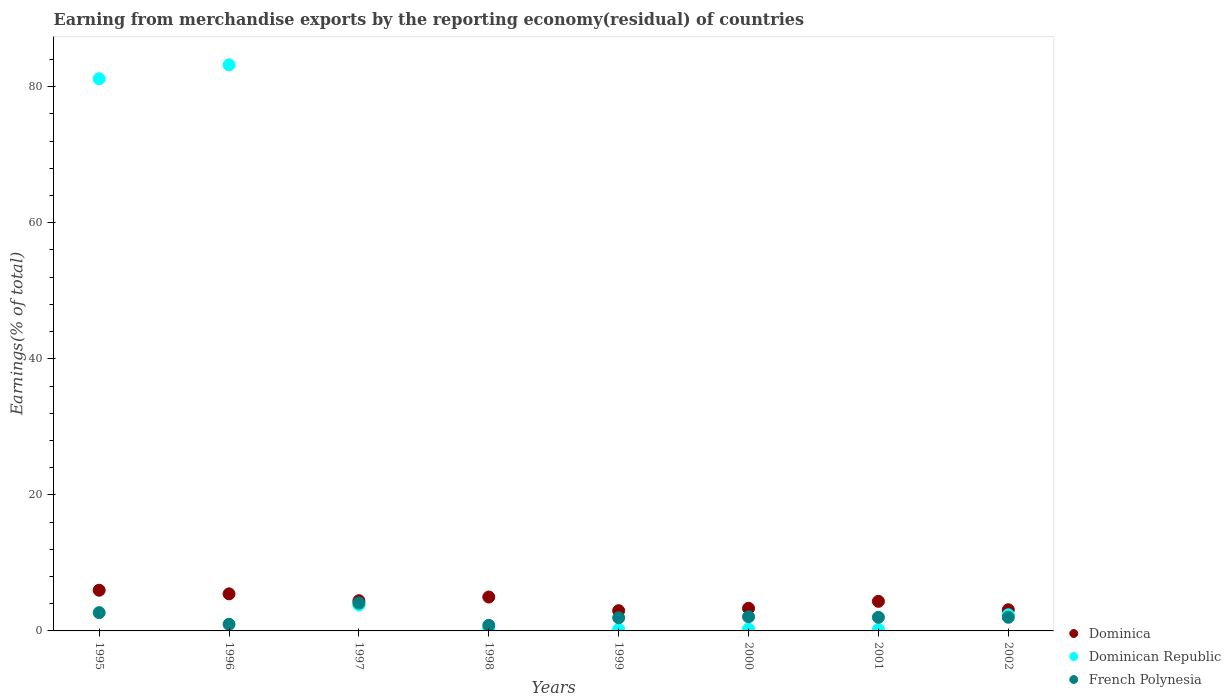How many different coloured dotlines are there?
Offer a terse response. 3. Is the number of dotlines equal to the number of legend labels?
Make the answer very short. Yes. What is the percentage of amount earned from merchandise exports in Dominica in 2001?
Offer a very short reply. 4.35. Across all years, what is the maximum percentage of amount earned from merchandise exports in French Polynesia?
Your answer should be very brief. 4.1. Across all years, what is the minimum percentage of amount earned from merchandise exports in Dominican Republic?
Keep it short and to the point. 0.22. In which year was the percentage of amount earned from merchandise exports in French Polynesia minimum?
Provide a succinct answer. 1998. What is the total percentage of amount earned from merchandise exports in Dominica in the graph?
Offer a terse response. 34.62. What is the difference between the percentage of amount earned from merchandise exports in French Polynesia in 1998 and that in 2001?
Ensure brevity in your answer.  -1.18. What is the difference between the percentage of amount earned from merchandise exports in Dominica in 1999 and the percentage of amount earned from merchandise exports in French Polynesia in 2000?
Offer a very short reply. 0.9. What is the average percentage of amount earned from merchandise exports in Dominican Republic per year?
Give a very brief answer. 21.45. In the year 2000, what is the difference between the percentage of amount earned from merchandise exports in Dominican Republic and percentage of amount earned from merchandise exports in French Polynesia?
Provide a succinct answer. -1.81. What is the ratio of the percentage of amount earned from merchandise exports in Dominican Republic in 1997 to that in 1998?
Provide a succinct answer. 11.71. Is the percentage of amount earned from merchandise exports in Dominica in 1996 less than that in 2001?
Your answer should be compact. No. Is the difference between the percentage of amount earned from merchandise exports in Dominican Republic in 1996 and 1999 greater than the difference between the percentage of amount earned from merchandise exports in French Polynesia in 1996 and 1999?
Offer a terse response. Yes. What is the difference between the highest and the second highest percentage of amount earned from merchandise exports in French Polynesia?
Your answer should be compact. 1.42. What is the difference between the highest and the lowest percentage of amount earned from merchandise exports in Dominican Republic?
Make the answer very short. 83. Does the percentage of amount earned from merchandise exports in Dominica monotonically increase over the years?
Ensure brevity in your answer.  No. Is the percentage of amount earned from merchandise exports in Dominican Republic strictly greater than the percentage of amount earned from merchandise exports in French Polynesia over the years?
Provide a succinct answer. No. Is the percentage of amount earned from merchandise exports in Dominican Republic strictly less than the percentage of amount earned from merchandise exports in French Polynesia over the years?
Keep it short and to the point. No. Does the graph contain any zero values?
Offer a terse response. No. How many legend labels are there?
Provide a short and direct response. 3. What is the title of the graph?
Your answer should be very brief. Earning from merchandise exports by the reporting economy(residual) of countries. Does "Romania" appear as one of the legend labels in the graph?
Provide a succinct answer. No. What is the label or title of the Y-axis?
Make the answer very short. Earnings(% of total). What is the Earnings(% of total) of Dominica in 1995?
Your answer should be compact. 5.98. What is the Earnings(% of total) of Dominican Republic in 1995?
Provide a succinct answer. 81.17. What is the Earnings(% of total) of French Polynesia in 1995?
Keep it short and to the point. 2.69. What is the Earnings(% of total) in Dominica in 1996?
Keep it short and to the point. 5.45. What is the Earnings(% of total) in Dominican Republic in 1996?
Your response must be concise. 83.22. What is the Earnings(% of total) of French Polynesia in 1996?
Offer a terse response. 0.98. What is the Earnings(% of total) in Dominica in 1997?
Your answer should be compact. 4.44. What is the Earnings(% of total) in Dominican Republic in 1997?
Provide a succinct answer. 3.8. What is the Earnings(% of total) of French Polynesia in 1997?
Keep it short and to the point. 4.1. What is the Earnings(% of total) in Dominica in 1998?
Provide a short and direct response. 4.98. What is the Earnings(% of total) of Dominican Republic in 1998?
Offer a very short reply. 0.32. What is the Earnings(% of total) in French Polynesia in 1998?
Your answer should be very brief. 0.82. What is the Earnings(% of total) in Dominica in 1999?
Provide a succinct answer. 2.97. What is the Earnings(% of total) of Dominican Republic in 1999?
Keep it short and to the point. 0.23. What is the Earnings(% of total) in French Polynesia in 1999?
Your answer should be very brief. 1.93. What is the Earnings(% of total) of Dominica in 2000?
Make the answer very short. 3.32. What is the Earnings(% of total) in Dominican Republic in 2000?
Make the answer very short. 0.27. What is the Earnings(% of total) in French Polynesia in 2000?
Provide a short and direct response. 2.08. What is the Earnings(% of total) of Dominica in 2001?
Give a very brief answer. 4.35. What is the Earnings(% of total) of Dominican Republic in 2001?
Provide a succinct answer. 0.22. What is the Earnings(% of total) of French Polynesia in 2001?
Offer a terse response. 2. What is the Earnings(% of total) in Dominica in 2002?
Provide a short and direct response. 3.11. What is the Earnings(% of total) in Dominican Republic in 2002?
Make the answer very short. 2.38. What is the Earnings(% of total) in French Polynesia in 2002?
Give a very brief answer. 2.01. Across all years, what is the maximum Earnings(% of total) in Dominica?
Offer a terse response. 5.98. Across all years, what is the maximum Earnings(% of total) of Dominican Republic?
Your response must be concise. 83.22. Across all years, what is the maximum Earnings(% of total) of French Polynesia?
Make the answer very short. 4.1. Across all years, what is the minimum Earnings(% of total) in Dominica?
Ensure brevity in your answer.  2.97. Across all years, what is the minimum Earnings(% of total) of Dominican Republic?
Your response must be concise. 0.22. Across all years, what is the minimum Earnings(% of total) in French Polynesia?
Offer a very short reply. 0.82. What is the total Earnings(% of total) of Dominica in the graph?
Make the answer very short. 34.62. What is the total Earnings(% of total) in Dominican Republic in the graph?
Keep it short and to the point. 171.61. What is the total Earnings(% of total) in French Polynesia in the graph?
Your response must be concise. 16.61. What is the difference between the Earnings(% of total) in Dominica in 1995 and that in 1996?
Ensure brevity in your answer.  0.53. What is the difference between the Earnings(% of total) in Dominican Republic in 1995 and that in 1996?
Ensure brevity in your answer.  -2.05. What is the difference between the Earnings(% of total) of French Polynesia in 1995 and that in 1996?
Your answer should be compact. 1.71. What is the difference between the Earnings(% of total) in Dominica in 1995 and that in 1997?
Keep it short and to the point. 1.54. What is the difference between the Earnings(% of total) of Dominican Republic in 1995 and that in 1997?
Your answer should be compact. 77.37. What is the difference between the Earnings(% of total) in French Polynesia in 1995 and that in 1997?
Make the answer very short. -1.42. What is the difference between the Earnings(% of total) in Dominica in 1995 and that in 1998?
Ensure brevity in your answer.  1. What is the difference between the Earnings(% of total) in Dominican Republic in 1995 and that in 1998?
Keep it short and to the point. 80.85. What is the difference between the Earnings(% of total) of French Polynesia in 1995 and that in 1998?
Your answer should be compact. 1.87. What is the difference between the Earnings(% of total) in Dominica in 1995 and that in 1999?
Make the answer very short. 3.01. What is the difference between the Earnings(% of total) of Dominican Republic in 1995 and that in 1999?
Ensure brevity in your answer.  80.94. What is the difference between the Earnings(% of total) of French Polynesia in 1995 and that in 1999?
Make the answer very short. 0.75. What is the difference between the Earnings(% of total) of Dominica in 1995 and that in 2000?
Your answer should be compact. 2.66. What is the difference between the Earnings(% of total) of Dominican Republic in 1995 and that in 2000?
Give a very brief answer. 80.9. What is the difference between the Earnings(% of total) of French Polynesia in 1995 and that in 2000?
Give a very brief answer. 0.61. What is the difference between the Earnings(% of total) in Dominica in 1995 and that in 2001?
Ensure brevity in your answer.  1.63. What is the difference between the Earnings(% of total) of Dominican Republic in 1995 and that in 2001?
Keep it short and to the point. 80.95. What is the difference between the Earnings(% of total) of French Polynesia in 1995 and that in 2001?
Offer a very short reply. 0.69. What is the difference between the Earnings(% of total) of Dominica in 1995 and that in 2002?
Provide a short and direct response. 2.87. What is the difference between the Earnings(% of total) in Dominican Republic in 1995 and that in 2002?
Provide a short and direct response. 78.79. What is the difference between the Earnings(% of total) in French Polynesia in 1995 and that in 2002?
Your response must be concise. 0.68. What is the difference between the Earnings(% of total) in Dominican Republic in 1996 and that in 1997?
Make the answer very short. 79.42. What is the difference between the Earnings(% of total) of French Polynesia in 1996 and that in 1997?
Your response must be concise. -3.13. What is the difference between the Earnings(% of total) of Dominica in 1996 and that in 1998?
Your answer should be compact. 0.47. What is the difference between the Earnings(% of total) of Dominican Republic in 1996 and that in 1998?
Keep it short and to the point. 82.9. What is the difference between the Earnings(% of total) in French Polynesia in 1996 and that in 1998?
Your answer should be very brief. 0.16. What is the difference between the Earnings(% of total) in Dominica in 1996 and that in 1999?
Provide a succinct answer. 2.47. What is the difference between the Earnings(% of total) in Dominican Republic in 1996 and that in 1999?
Ensure brevity in your answer.  82.99. What is the difference between the Earnings(% of total) in French Polynesia in 1996 and that in 1999?
Your answer should be very brief. -0.96. What is the difference between the Earnings(% of total) of Dominica in 1996 and that in 2000?
Your response must be concise. 2.13. What is the difference between the Earnings(% of total) in Dominican Republic in 1996 and that in 2000?
Your answer should be very brief. 82.95. What is the difference between the Earnings(% of total) in French Polynesia in 1996 and that in 2000?
Give a very brief answer. -1.1. What is the difference between the Earnings(% of total) in Dominica in 1996 and that in 2001?
Offer a very short reply. 1.1. What is the difference between the Earnings(% of total) of Dominican Republic in 1996 and that in 2001?
Your answer should be compact. 83. What is the difference between the Earnings(% of total) of French Polynesia in 1996 and that in 2001?
Give a very brief answer. -1.02. What is the difference between the Earnings(% of total) in Dominica in 1996 and that in 2002?
Offer a very short reply. 2.34. What is the difference between the Earnings(% of total) of Dominican Republic in 1996 and that in 2002?
Your answer should be very brief. 80.84. What is the difference between the Earnings(% of total) of French Polynesia in 1996 and that in 2002?
Provide a succinct answer. -1.03. What is the difference between the Earnings(% of total) of Dominica in 1997 and that in 1998?
Your answer should be compact. -0.54. What is the difference between the Earnings(% of total) in Dominican Republic in 1997 and that in 1998?
Offer a very short reply. 3.48. What is the difference between the Earnings(% of total) of French Polynesia in 1997 and that in 1998?
Provide a short and direct response. 3.28. What is the difference between the Earnings(% of total) of Dominica in 1997 and that in 1999?
Ensure brevity in your answer.  1.47. What is the difference between the Earnings(% of total) in Dominican Republic in 1997 and that in 1999?
Make the answer very short. 3.58. What is the difference between the Earnings(% of total) in French Polynesia in 1997 and that in 1999?
Give a very brief answer. 2.17. What is the difference between the Earnings(% of total) in Dominica in 1997 and that in 2000?
Offer a terse response. 1.12. What is the difference between the Earnings(% of total) of Dominican Republic in 1997 and that in 2000?
Make the answer very short. 3.53. What is the difference between the Earnings(% of total) in French Polynesia in 1997 and that in 2000?
Give a very brief answer. 2.03. What is the difference between the Earnings(% of total) of Dominica in 1997 and that in 2001?
Give a very brief answer. 0.09. What is the difference between the Earnings(% of total) of Dominican Republic in 1997 and that in 2001?
Your answer should be compact. 3.58. What is the difference between the Earnings(% of total) in French Polynesia in 1997 and that in 2001?
Provide a short and direct response. 2.1. What is the difference between the Earnings(% of total) of Dominica in 1997 and that in 2002?
Provide a succinct answer. 1.33. What is the difference between the Earnings(% of total) in Dominican Republic in 1997 and that in 2002?
Keep it short and to the point. 1.43. What is the difference between the Earnings(% of total) in French Polynesia in 1997 and that in 2002?
Your answer should be compact. 2.1. What is the difference between the Earnings(% of total) of Dominica in 1998 and that in 1999?
Keep it short and to the point. 2.01. What is the difference between the Earnings(% of total) of Dominican Republic in 1998 and that in 1999?
Keep it short and to the point. 0.1. What is the difference between the Earnings(% of total) of French Polynesia in 1998 and that in 1999?
Your answer should be very brief. -1.11. What is the difference between the Earnings(% of total) in Dominica in 1998 and that in 2000?
Ensure brevity in your answer.  1.66. What is the difference between the Earnings(% of total) in Dominican Republic in 1998 and that in 2000?
Keep it short and to the point. 0.05. What is the difference between the Earnings(% of total) of French Polynesia in 1998 and that in 2000?
Keep it short and to the point. -1.26. What is the difference between the Earnings(% of total) of Dominica in 1998 and that in 2001?
Keep it short and to the point. 0.63. What is the difference between the Earnings(% of total) in Dominican Republic in 1998 and that in 2001?
Ensure brevity in your answer.  0.1. What is the difference between the Earnings(% of total) of French Polynesia in 1998 and that in 2001?
Ensure brevity in your answer.  -1.18. What is the difference between the Earnings(% of total) in Dominica in 1998 and that in 2002?
Keep it short and to the point. 1.87. What is the difference between the Earnings(% of total) of Dominican Republic in 1998 and that in 2002?
Your answer should be compact. -2.05. What is the difference between the Earnings(% of total) in French Polynesia in 1998 and that in 2002?
Offer a very short reply. -1.19. What is the difference between the Earnings(% of total) in Dominica in 1999 and that in 2000?
Your answer should be compact. -0.35. What is the difference between the Earnings(% of total) in Dominican Republic in 1999 and that in 2000?
Give a very brief answer. -0.05. What is the difference between the Earnings(% of total) in French Polynesia in 1999 and that in 2000?
Keep it short and to the point. -0.14. What is the difference between the Earnings(% of total) of Dominica in 1999 and that in 2001?
Keep it short and to the point. -1.38. What is the difference between the Earnings(% of total) of Dominican Republic in 1999 and that in 2001?
Your answer should be compact. 0.01. What is the difference between the Earnings(% of total) in French Polynesia in 1999 and that in 2001?
Ensure brevity in your answer.  -0.07. What is the difference between the Earnings(% of total) of Dominica in 1999 and that in 2002?
Provide a short and direct response. -0.14. What is the difference between the Earnings(% of total) of Dominican Republic in 1999 and that in 2002?
Offer a terse response. -2.15. What is the difference between the Earnings(% of total) in French Polynesia in 1999 and that in 2002?
Offer a terse response. -0.08. What is the difference between the Earnings(% of total) of Dominica in 2000 and that in 2001?
Keep it short and to the point. -1.03. What is the difference between the Earnings(% of total) in Dominican Republic in 2000 and that in 2001?
Give a very brief answer. 0.05. What is the difference between the Earnings(% of total) in French Polynesia in 2000 and that in 2001?
Offer a terse response. 0.08. What is the difference between the Earnings(% of total) in Dominica in 2000 and that in 2002?
Your response must be concise. 0.21. What is the difference between the Earnings(% of total) of Dominican Republic in 2000 and that in 2002?
Keep it short and to the point. -2.1. What is the difference between the Earnings(% of total) in French Polynesia in 2000 and that in 2002?
Provide a succinct answer. 0.07. What is the difference between the Earnings(% of total) of Dominica in 2001 and that in 2002?
Ensure brevity in your answer.  1.24. What is the difference between the Earnings(% of total) of Dominican Republic in 2001 and that in 2002?
Your response must be concise. -2.15. What is the difference between the Earnings(% of total) of French Polynesia in 2001 and that in 2002?
Keep it short and to the point. -0.01. What is the difference between the Earnings(% of total) in Dominica in 1995 and the Earnings(% of total) in Dominican Republic in 1996?
Give a very brief answer. -77.24. What is the difference between the Earnings(% of total) of Dominica in 1995 and the Earnings(% of total) of French Polynesia in 1996?
Provide a short and direct response. 5. What is the difference between the Earnings(% of total) in Dominican Republic in 1995 and the Earnings(% of total) in French Polynesia in 1996?
Provide a succinct answer. 80.19. What is the difference between the Earnings(% of total) of Dominica in 1995 and the Earnings(% of total) of Dominican Republic in 1997?
Your answer should be very brief. 2.18. What is the difference between the Earnings(% of total) in Dominica in 1995 and the Earnings(% of total) in French Polynesia in 1997?
Give a very brief answer. 1.88. What is the difference between the Earnings(% of total) in Dominican Republic in 1995 and the Earnings(% of total) in French Polynesia in 1997?
Give a very brief answer. 77.07. What is the difference between the Earnings(% of total) of Dominica in 1995 and the Earnings(% of total) of Dominican Republic in 1998?
Offer a very short reply. 5.66. What is the difference between the Earnings(% of total) of Dominica in 1995 and the Earnings(% of total) of French Polynesia in 1998?
Provide a short and direct response. 5.16. What is the difference between the Earnings(% of total) of Dominican Republic in 1995 and the Earnings(% of total) of French Polynesia in 1998?
Provide a succinct answer. 80.35. What is the difference between the Earnings(% of total) of Dominica in 1995 and the Earnings(% of total) of Dominican Republic in 1999?
Make the answer very short. 5.76. What is the difference between the Earnings(% of total) in Dominica in 1995 and the Earnings(% of total) in French Polynesia in 1999?
Give a very brief answer. 4.05. What is the difference between the Earnings(% of total) of Dominican Republic in 1995 and the Earnings(% of total) of French Polynesia in 1999?
Provide a short and direct response. 79.24. What is the difference between the Earnings(% of total) of Dominica in 1995 and the Earnings(% of total) of Dominican Republic in 2000?
Make the answer very short. 5.71. What is the difference between the Earnings(% of total) in Dominica in 1995 and the Earnings(% of total) in French Polynesia in 2000?
Make the answer very short. 3.9. What is the difference between the Earnings(% of total) in Dominican Republic in 1995 and the Earnings(% of total) in French Polynesia in 2000?
Provide a succinct answer. 79.09. What is the difference between the Earnings(% of total) in Dominica in 1995 and the Earnings(% of total) in Dominican Republic in 2001?
Your response must be concise. 5.76. What is the difference between the Earnings(% of total) in Dominica in 1995 and the Earnings(% of total) in French Polynesia in 2001?
Ensure brevity in your answer.  3.98. What is the difference between the Earnings(% of total) of Dominican Republic in 1995 and the Earnings(% of total) of French Polynesia in 2001?
Make the answer very short. 79.17. What is the difference between the Earnings(% of total) in Dominica in 1995 and the Earnings(% of total) in Dominican Republic in 2002?
Your answer should be compact. 3.61. What is the difference between the Earnings(% of total) of Dominica in 1995 and the Earnings(% of total) of French Polynesia in 2002?
Your answer should be compact. 3.97. What is the difference between the Earnings(% of total) in Dominican Republic in 1995 and the Earnings(% of total) in French Polynesia in 2002?
Your answer should be very brief. 79.16. What is the difference between the Earnings(% of total) of Dominica in 1996 and the Earnings(% of total) of Dominican Republic in 1997?
Make the answer very short. 1.65. What is the difference between the Earnings(% of total) of Dominica in 1996 and the Earnings(% of total) of French Polynesia in 1997?
Your answer should be very brief. 1.34. What is the difference between the Earnings(% of total) in Dominican Republic in 1996 and the Earnings(% of total) in French Polynesia in 1997?
Your answer should be very brief. 79.12. What is the difference between the Earnings(% of total) of Dominica in 1996 and the Earnings(% of total) of Dominican Republic in 1998?
Offer a terse response. 5.12. What is the difference between the Earnings(% of total) in Dominica in 1996 and the Earnings(% of total) in French Polynesia in 1998?
Ensure brevity in your answer.  4.63. What is the difference between the Earnings(% of total) of Dominican Republic in 1996 and the Earnings(% of total) of French Polynesia in 1998?
Offer a terse response. 82.4. What is the difference between the Earnings(% of total) in Dominica in 1996 and the Earnings(% of total) in Dominican Republic in 1999?
Keep it short and to the point. 5.22. What is the difference between the Earnings(% of total) in Dominica in 1996 and the Earnings(% of total) in French Polynesia in 1999?
Your answer should be compact. 3.51. What is the difference between the Earnings(% of total) in Dominican Republic in 1996 and the Earnings(% of total) in French Polynesia in 1999?
Provide a succinct answer. 81.29. What is the difference between the Earnings(% of total) in Dominica in 1996 and the Earnings(% of total) in Dominican Republic in 2000?
Your response must be concise. 5.18. What is the difference between the Earnings(% of total) in Dominica in 1996 and the Earnings(% of total) in French Polynesia in 2000?
Offer a very short reply. 3.37. What is the difference between the Earnings(% of total) of Dominican Republic in 1996 and the Earnings(% of total) of French Polynesia in 2000?
Ensure brevity in your answer.  81.14. What is the difference between the Earnings(% of total) in Dominica in 1996 and the Earnings(% of total) in Dominican Republic in 2001?
Keep it short and to the point. 5.23. What is the difference between the Earnings(% of total) in Dominica in 1996 and the Earnings(% of total) in French Polynesia in 2001?
Your response must be concise. 3.45. What is the difference between the Earnings(% of total) in Dominican Republic in 1996 and the Earnings(% of total) in French Polynesia in 2001?
Your answer should be compact. 81.22. What is the difference between the Earnings(% of total) of Dominica in 1996 and the Earnings(% of total) of Dominican Republic in 2002?
Your answer should be compact. 3.07. What is the difference between the Earnings(% of total) in Dominica in 1996 and the Earnings(% of total) in French Polynesia in 2002?
Offer a terse response. 3.44. What is the difference between the Earnings(% of total) of Dominican Republic in 1996 and the Earnings(% of total) of French Polynesia in 2002?
Your answer should be compact. 81.21. What is the difference between the Earnings(% of total) of Dominica in 1997 and the Earnings(% of total) of Dominican Republic in 1998?
Give a very brief answer. 4.12. What is the difference between the Earnings(% of total) in Dominica in 1997 and the Earnings(% of total) in French Polynesia in 1998?
Provide a succinct answer. 3.62. What is the difference between the Earnings(% of total) in Dominican Republic in 1997 and the Earnings(% of total) in French Polynesia in 1998?
Provide a short and direct response. 2.98. What is the difference between the Earnings(% of total) of Dominica in 1997 and the Earnings(% of total) of Dominican Republic in 1999?
Your response must be concise. 4.22. What is the difference between the Earnings(% of total) in Dominica in 1997 and the Earnings(% of total) in French Polynesia in 1999?
Your answer should be compact. 2.51. What is the difference between the Earnings(% of total) of Dominican Republic in 1997 and the Earnings(% of total) of French Polynesia in 1999?
Ensure brevity in your answer.  1.87. What is the difference between the Earnings(% of total) of Dominica in 1997 and the Earnings(% of total) of Dominican Republic in 2000?
Give a very brief answer. 4.17. What is the difference between the Earnings(% of total) of Dominica in 1997 and the Earnings(% of total) of French Polynesia in 2000?
Offer a very short reply. 2.36. What is the difference between the Earnings(% of total) of Dominican Republic in 1997 and the Earnings(% of total) of French Polynesia in 2000?
Offer a very short reply. 1.72. What is the difference between the Earnings(% of total) of Dominica in 1997 and the Earnings(% of total) of Dominican Republic in 2001?
Ensure brevity in your answer.  4.22. What is the difference between the Earnings(% of total) in Dominica in 1997 and the Earnings(% of total) in French Polynesia in 2001?
Provide a succinct answer. 2.44. What is the difference between the Earnings(% of total) in Dominican Republic in 1997 and the Earnings(% of total) in French Polynesia in 2001?
Make the answer very short. 1.8. What is the difference between the Earnings(% of total) in Dominica in 1997 and the Earnings(% of total) in Dominican Republic in 2002?
Keep it short and to the point. 2.07. What is the difference between the Earnings(% of total) in Dominica in 1997 and the Earnings(% of total) in French Polynesia in 2002?
Give a very brief answer. 2.43. What is the difference between the Earnings(% of total) in Dominican Republic in 1997 and the Earnings(% of total) in French Polynesia in 2002?
Make the answer very short. 1.79. What is the difference between the Earnings(% of total) of Dominica in 1998 and the Earnings(% of total) of Dominican Republic in 1999?
Give a very brief answer. 4.76. What is the difference between the Earnings(% of total) in Dominica in 1998 and the Earnings(% of total) in French Polynesia in 1999?
Give a very brief answer. 3.05. What is the difference between the Earnings(% of total) in Dominican Republic in 1998 and the Earnings(% of total) in French Polynesia in 1999?
Make the answer very short. -1.61. What is the difference between the Earnings(% of total) of Dominica in 1998 and the Earnings(% of total) of Dominican Republic in 2000?
Ensure brevity in your answer.  4.71. What is the difference between the Earnings(% of total) of Dominica in 1998 and the Earnings(% of total) of French Polynesia in 2000?
Your response must be concise. 2.9. What is the difference between the Earnings(% of total) of Dominican Republic in 1998 and the Earnings(% of total) of French Polynesia in 2000?
Your response must be concise. -1.75. What is the difference between the Earnings(% of total) in Dominica in 1998 and the Earnings(% of total) in Dominican Republic in 2001?
Ensure brevity in your answer.  4.76. What is the difference between the Earnings(% of total) in Dominica in 1998 and the Earnings(% of total) in French Polynesia in 2001?
Your answer should be very brief. 2.98. What is the difference between the Earnings(% of total) in Dominican Republic in 1998 and the Earnings(% of total) in French Polynesia in 2001?
Provide a succinct answer. -1.68. What is the difference between the Earnings(% of total) of Dominica in 1998 and the Earnings(% of total) of Dominican Republic in 2002?
Offer a very short reply. 2.61. What is the difference between the Earnings(% of total) in Dominica in 1998 and the Earnings(% of total) in French Polynesia in 2002?
Your answer should be very brief. 2.97. What is the difference between the Earnings(% of total) in Dominican Republic in 1998 and the Earnings(% of total) in French Polynesia in 2002?
Give a very brief answer. -1.68. What is the difference between the Earnings(% of total) in Dominica in 1999 and the Earnings(% of total) in Dominican Republic in 2000?
Your answer should be compact. 2.7. What is the difference between the Earnings(% of total) of Dominica in 1999 and the Earnings(% of total) of French Polynesia in 2000?
Ensure brevity in your answer.  0.9. What is the difference between the Earnings(% of total) in Dominican Republic in 1999 and the Earnings(% of total) in French Polynesia in 2000?
Offer a terse response. -1.85. What is the difference between the Earnings(% of total) in Dominica in 1999 and the Earnings(% of total) in Dominican Republic in 2001?
Make the answer very short. 2.75. What is the difference between the Earnings(% of total) in Dominica in 1999 and the Earnings(% of total) in French Polynesia in 2001?
Keep it short and to the point. 0.97. What is the difference between the Earnings(% of total) in Dominican Republic in 1999 and the Earnings(% of total) in French Polynesia in 2001?
Provide a succinct answer. -1.77. What is the difference between the Earnings(% of total) of Dominica in 1999 and the Earnings(% of total) of Dominican Republic in 2002?
Make the answer very short. 0.6. What is the difference between the Earnings(% of total) in Dominica in 1999 and the Earnings(% of total) in French Polynesia in 2002?
Offer a terse response. 0.96. What is the difference between the Earnings(% of total) of Dominican Republic in 1999 and the Earnings(% of total) of French Polynesia in 2002?
Give a very brief answer. -1.78. What is the difference between the Earnings(% of total) in Dominica in 2000 and the Earnings(% of total) in Dominican Republic in 2001?
Keep it short and to the point. 3.1. What is the difference between the Earnings(% of total) in Dominica in 2000 and the Earnings(% of total) in French Polynesia in 2001?
Provide a succinct answer. 1.32. What is the difference between the Earnings(% of total) in Dominican Republic in 2000 and the Earnings(% of total) in French Polynesia in 2001?
Provide a succinct answer. -1.73. What is the difference between the Earnings(% of total) of Dominica in 2000 and the Earnings(% of total) of Dominican Republic in 2002?
Keep it short and to the point. 0.95. What is the difference between the Earnings(% of total) in Dominica in 2000 and the Earnings(% of total) in French Polynesia in 2002?
Your response must be concise. 1.31. What is the difference between the Earnings(% of total) of Dominican Republic in 2000 and the Earnings(% of total) of French Polynesia in 2002?
Ensure brevity in your answer.  -1.74. What is the difference between the Earnings(% of total) of Dominica in 2001 and the Earnings(% of total) of Dominican Republic in 2002?
Give a very brief answer. 1.97. What is the difference between the Earnings(% of total) of Dominica in 2001 and the Earnings(% of total) of French Polynesia in 2002?
Provide a succinct answer. 2.34. What is the difference between the Earnings(% of total) of Dominican Republic in 2001 and the Earnings(% of total) of French Polynesia in 2002?
Ensure brevity in your answer.  -1.79. What is the average Earnings(% of total) of Dominica per year?
Give a very brief answer. 4.33. What is the average Earnings(% of total) in Dominican Republic per year?
Offer a terse response. 21.45. What is the average Earnings(% of total) in French Polynesia per year?
Make the answer very short. 2.08. In the year 1995, what is the difference between the Earnings(% of total) in Dominica and Earnings(% of total) in Dominican Republic?
Your answer should be compact. -75.19. In the year 1995, what is the difference between the Earnings(% of total) of Dominica and Earnings(% of total) of French Polynesia?
Give a very brief answer. 3.29. In the year 1995, what is the difference between the Earnings(% of total) in Dominican Republic and Earnings(% of total) in French Polynesia?
Give a very brief answer. 78.48. In the year 1996, what is the difference between the Earnings(% of total) in Dominica and Earnings(% of total) in Dominican Republic?
Provide a short and direct response. -77.77. In the year 1996, what is the difference between the Earnings(% of total) of Dominica and Earnings(% of total) of French Polynesia?
Provide a succinct answer. 4.47. In the year 1996, what is the difference between the Earnings(% of total) in Dominican Republic and Earnings(% of total) in French Polynesia?
Make the answer very short. 82.24. In the year 1997, what is the difference between the Earnings(% of total) in Dominica and Earnings(% of total) in Dominican Republic?
Your answer should be compact. 0.64. In the year 1997, what is the difference between the Earnings(% of total) of Dominica and Earnings(% of total) of French Polynesia?
Give a very brief answer. 0.34. In the year 1997, what is the difference between the Earnings(% of total) of Dominican Republic and Earnings(% of total) of French Polynesia?
Offer a very short reply. -0.3. In the year 1998, what is the difference between the Earnings(% of total) in Dominica and Earnings(% of total) in Dominican Republic?
Give a very brief answer. 4.66. In the year 1998, what is the difference between the Earnings(% of total) of Dominica and Earnings(% of total) of French Polynesia?
Keep it short and to the point. 4.16. In the year 1998, what is the difference between the Earnings(% of total) in Dominican Republic and Earnings(% of total) in French Polynesia?
Offer a very short reply. -0.5. In the year 1999, what is the difference between the Earnings(% of total) of Dominica and Earnings(% of total) of Dominican Republic?
Your answer should be compact. 2.75. In the year 1999, what is the difference between the Earnings(% of total) in Dominica and Earnings(% of total) in French Polynesia?
Your response must be concise. 1.04. In the year 1999, what is the difference between the Earnings(% of total) of Dominican Republic and Earnings(% of total) of French Polynesia?
Your answer should be very brief. -1.71. In the year 2000, what is the difference between the Earnings(% of total) in Dominica and Earnings(% of total) in Dominican Republic?
Offer a very short reply. 3.05. In the year 2000, what is the difference between the Earnings(% of total) of Dominica and Earnings(% of total) of French Polynesia?
Provide a succinct answer. 1.24. In the year 2000, what is the difference between the Earnings(% of total) of Dominican Republic and Earnings(% of total) of French Polynesia?
Your answer should be very brief. -1.81. In the year 2001, what is the difference between the Earnings(% of total) in Dominica and Earnings(% of total) in Dominican Republic?
Make the answer very short. 4.13. In the year 2001, what is the difference between the Earnings(% of total) in Dominica and Earnings(% of total) in French Polynesia?
Ensure brevity in your answer.  2.35. In the year 2001, what is the difference between the Earnings(% of total) in Dominican Republic and Earnings(% of total) in French Polynesia?
Your answer should be very brief. -1.78. In the year 2002, what is the difference between the Earnings(% of total) in Dominica and Earnings(% of total) in Dominican Republic?
Your response must be concise. 0.73. In the year 2002, what is the difference between the Earnings(% of total) in Dominica and Earnings(% of total) in French Polynesia?
Provide a succinct answer. 1.1. In the year 2002, what is the difference between the Earnings(% of total) of Dominican Republic and Earnings(% of total) of French Polynesia?
Keep it short and to the point. 0.37. What is the ratio of the Earnings(% of total) in Dominica in 1995 to that in 1996?
Provide a short and direct response. 1.1. What is the ratio of the Earnings(% of total) of Dominican Republic in 1995 to that in 1996?
Your answer should be compact. 0.98. What is the ratio of the Earnings(% of total) of French Polynesia in 1995 to that in 1996?
Your answer should be very brief. 2.75. What is the ratio of the Earnings(% of total) in Dominica in 1995 to that in 1997?
Make the answer very short. 1.35. What is the ratio of the Earnings(% of total) of Dominican Republic in 1995 to that in 1997?
Give a very brief answer. 21.35. What is the ratio of the Earnings(% of total) of French Polynesia in 1995 to that in 1997?
Your answer should be compact. 0.66. What is the ratio of the Earnings(% of total) of Dominica in 1995 to that in 1998?
Give a very brief answer. 1.2. What is the ratio of the Earnings(% of total) in Dominican Republic in 1995 to that in 1998?
Offer a very short reply. 250.01. What is the ratio of the Earnings(% of total) of French Polynesia in 1995 to that in 1998?
Ensure brevity in your answer.  3.28. What is the ratio of the Earnings(% of total) of Dominica in 1995 to that in 1999?
Provide a short and direct response. 2.01. What is the ratio of the Earnings(% of total) of Dominican Republic in 1995 to that in 1999?
Give a very brief answer. 358.83. What is the ratio of the Earnings(% of total) in French Polynesia in 1995 to that in 1999?
Offer a very short reply. 1.39. What is the ratio of the Earnings(% of total) in Dominica in 1995 to that in 2000?
Your response must be concise. 1.8. What is the ratio of the Earnings(% of total) of Dominican Republic in 1995 to that in 2000?
Your answer should be very brief. 297.75. What is the ratio of the Earnings(% of total) of French Polynesia in 1995 to that in 2000?
Your answer should be very brief. 1.29. What is the ratio of the Earnings(% of total) of Dominica in 1995 to that in 2001?
Your response must be concise. 1.37. What is the ratio of the Earnings(% of total) in Dominican Republic in 1995 to that in 2001?
Offer a very short reply. 366.92. What is the ratio of the Earnings(% of total) of French Polynesia in 1995 to that in 2001?
Provide a short and direct response. 1.34. What is the ratio of the Earnings(% of total) of Dominica in 1995 to that in 2002?
Your answer should be compact. 1.92. What is the ratio of the Earnings(% of total) of Dominican Republic in 1995 to that in 2002?
Provide a short and direct response. 34.16. What is the ratio of the Earnings(% of total) in French Polynesia in 1995 to that in 2002?
Your answer should be compact. 1.34. What is the ratio of the Earnings(% of total) in Dominica in 1996 to that in 1997?
Your response must be concise. 1.23. What is the ratio of the Earnings(% of total) of Dominican Republic in 1996 to that in 1997?
Keep it short and to the point. 21.88. What is the ratio of the Earnings(% of total) in French Polynesia in 1996 to that in 1997?
Your response must be concise. 0.24. What is the ratio of the Earnings(% of total) in Dominica in 1996 to that in 1998?
Your response must be concise. 1.09. What is the ratio of the Earnings(% of total) of Dominican Republic in 1996 to that in 1998?
Offer a very short reply. 256.32. What is the ratio of the Earnings(% of total) of French Polynesia in 1996 to that in 1998?
Your answer should be compact. 1.19. What is the ratio of the Earnings(% of total) of Dominica in 1996 to that in 1999?
Your answer should be compact. 1.83. What is the ratio of the Earnings(% of total) in Dominican Republic in 1996 to that in 1999?
Keep it short and to the point. 367.89. What is the ratio of the Earnings(% of total) of French Polynesia in 1996 to that in 1999?
Give a very brief answer. 0.51. What is the ratio of the Earnings(% of total) in Dominica in 1996 to that in 2000?
Offer a terse response. 1.64. What is the ratio of the Earnings(% of total) of Dominican Republic in 1996 to that in 2000?
Your answer should be very brief. 305.26. What is the ratio of the Earnings(% of total) in French Polynesia in 1996 to that in 2000?
Your answer should be compact. 0.47. What is the ratio of the Earnings(% of total) in Dominica in 1996 to that in 2001?
Provide a succinct answer. 1.25. What is the ratio of the Earnings(% of total) of Dominican Republic in 1996 to that in 2001?
Your answer should be compact. 376.18. What is the ratio of the Earnings(% of total) in French Polynesia in 1996 to that in 2001?
Provide a short and direct response. 0.49. What is the ratio of the Earnings(% of total) of Dominica in 1996 to that in 2002?
Make the answer very short. 1.75. What is the ratio of the Earnings(% of total) in Dominican Republic in 1996 to that in 2002?
Offer a terse response. 35.02. What is the ratio of the Earnings(% of total) of French Polynesia in 1996 to that in 2002?
Make the answer very short. 0.49. What is the ratio of the Earnings(% of total) in Dominica in 1997 to that in 1998?
Keep it short and to the point. 0.89. What is the ratio of the Earnings(% of total) in Dominican Republic in 1997 to that in 1998?
Give a very brief answer. 11.71. What is the ratio of the Earnings(% of total) in French Polynesia in 1997 to that in 1998?
Provide a short and direct response. 5.01. What is the ratio of the Earnings(% of total) in Dominica in 1997 to that in 1999?
Give a very brief answer. 1.49. What is the ratio of the Earnings(% of total) of Dominican Republic in 1997 to that in 1999?
Provide a succinct answer. 16.81. What is the ratio of the Earnings(% of total) of French Polynesia in 1997 to that in 1999?
Keep it short and to the point. 2.12. What is the ratio of the Earnings(% of total) of Dominica in 1997 to that in 2000?
Provide a short and direct response. 1.34. What is the ratio of the Earnings(% of total) of Dominican Republic in 1997 to that in 2000?
Offer a terse response. 13.95. What is the ratio of the Earnings(% of total) in French Polynesia in 1997 to that in 2000?
Your answer should be very brief. 1.97. What is the ratio of the Earnings(% of total) of Dominica in 1997 to that in 2001?
Offer a terse response. 1.02. What is the ratio of the Earnings(% of total) in Dominican Republic in 1997 to that in 2001?
Your answer should be very brief. 17.19. What is the ratio of the Earnings(% of total) of French Polynesia in 1997 to that in 2001?
Your answer should be compact. 2.05. What is the ratio of the Earnings(% of total) in Dominica in 1997 to that in 2002?
Ensure brevity in your answer.  1.43. What is the ratio of the Earnings(% of total) in Dominican Republic in 1997 to that in 2002?
Your answer should be compact. 1.6. What is the ratio of the Earnings(% of total) in French Polynesia in 1997 to that in 2002?
Offer a very short reply. 2.04. What is the ratio of the Earnings(% of total) in Dominica in 1998 to that in 1999?
Offer a terse response. 1.68. What is the ratio of the Earnings(% of total) of Dominican Republic in 1998 to that in 1999?
Your answer should be very brief. 1.44. What is the ratio of the Earnings(% of total) of French Polynesia in 1998 to that in 1999?
Make the answer very short. 0.42. What is the ratio of the Earnings(% of total) in Dominica in 1998 to that in 2000?
Offer a terse response. 1.5. What is the ratio of the Earnings(% of total) of Dominican Republic in 1998 to that in 2000?
Make the answer very short. 1.19. What is the ratio of the Earnings(% of total) in French Polynesia in 1998 to that in 2000?
Your answer should be very brief. 0.39. What is the ratio of the Earnings(% of total) of Dominica in 1998 to that in 2001?
Keep it short and to the point. 1.15. What is the ratio of the Earnings(% of total) of Dominican Republic in 1998 to that in 2001?
Ensure brevity in your answer.  1.47. What is the ratio of the Earnings(% of total) in French Polynesia in 1998 to that in 2001?
Give a very brief answer. 0.41. What is the ratio of the Earnings(% of total) in Dominica in 1998 to that in 2002?
Offer a very short reply. 1.6. What is the ratio of the Earnings(% of total) in Dominican Republic in 1998 to that in 2002?
Your answer should be compact. 0.14. What is the ratio of the Earnings(% of total) in French Polynesia in 1998 to that in 2002?
Give a very brief answer. 0.41. What is the ratio of the Earnings(% of total) of Dominica in 1999 to that in 2000?
Ensure brevity in your answer.  0.89. What is the ratio of the Earnings(% of total) of Dominican Republic in 1999 to that in 2000?
Ensure brevity in your answer.  0.83. What is the ratio of the Earnings(% of total) of French Polynesia in 1999 to that in 2000?
Offer a very short reply. 0.93. What is the ratio of the Earnings(% of total) in Dominica in 1999 to that in 2001?
Keep it short and to the point. 0.68. What is the ratio of the Earnings(% of total) of Dominican Republic in 1999 to that in 2001?
Your answer should be compact. 1.02. What is the ratio of the Earnings(% of total) in French Polynesia in 1999 to that in 2001?
Give a very brief answer. 0.97. What is the ratio of the Earnings(% of total) in Dominica in 1999 to that in 2002?
Provide a short and direct response. 0.96. What is the ratio of the Earnings(% of total) of Dominican Republic in 1999 to that in 2002?
Give a very brief answer. 0.1. What is the ratio of the Earnings(% of total) of French Polynesia in 1999 to that in 2002?
Offer a terse response. 0.96. What is the ratio of the Earnings(% of total) in Dominica in 2000 to that in 2001?
Offer a very short reply. 0.76. What is the ratio of the Earnings(% of total) of Dominican Republic in 2000 to that in 2001?
Provide a succinct answer. 1.23. What is the ratio of the Earnings(% of total) in French Polynesia in 2000 to that in 2001?
Your answer should be compact. 1.04. What is the ratio of the Earnings(% of total) of Dominica in 2000 to that in 2002?
Provide a succinct answer. 1.07. What is the ratio of the Earnings(% of total) of Dominican Republic in 2000 to that in 2002?
Give a very brief answer. 0.11. What is the ratio of the Earnings(% of total) in French Polynesia in 2000 to that in 2002?
Make the answer very short. 1.03. What is the ratio of the Earnings(% of total) of Dominica in 2001 to that in 2002?
Ensure brevity in your answer.  1.4. What is the ratio of the Earnings(% of total) in Dominican Republic in 2001 to that in 2002?
Offer a very short reply. 0.09. What is the difference between the highest and the second highest Earnings(% of total) in Dominica?
Your answer should be compact. 0.53. What is the difference between the highest and the second highest Earnings(% of total) in Dominican Republic?
Your answer should be very brief. 2.05. What is the difference between the highest and the second highest Earnings(% of total) of French Polynesia?
Ensure brevity in your answer.  1.42. What is the difference between the highest and the lowest Earnings(% of total) in Dominica?
Provide a short and direct response. 3.01. What is the difference between the highest and the lowest Earnings(% of total) of Dominican Republic?
Offer a very short reply. 83. What is the difference between the highest and the lowest Earnings(% of total) of French Polynesia?
Offer a very short reply. 3.28. 